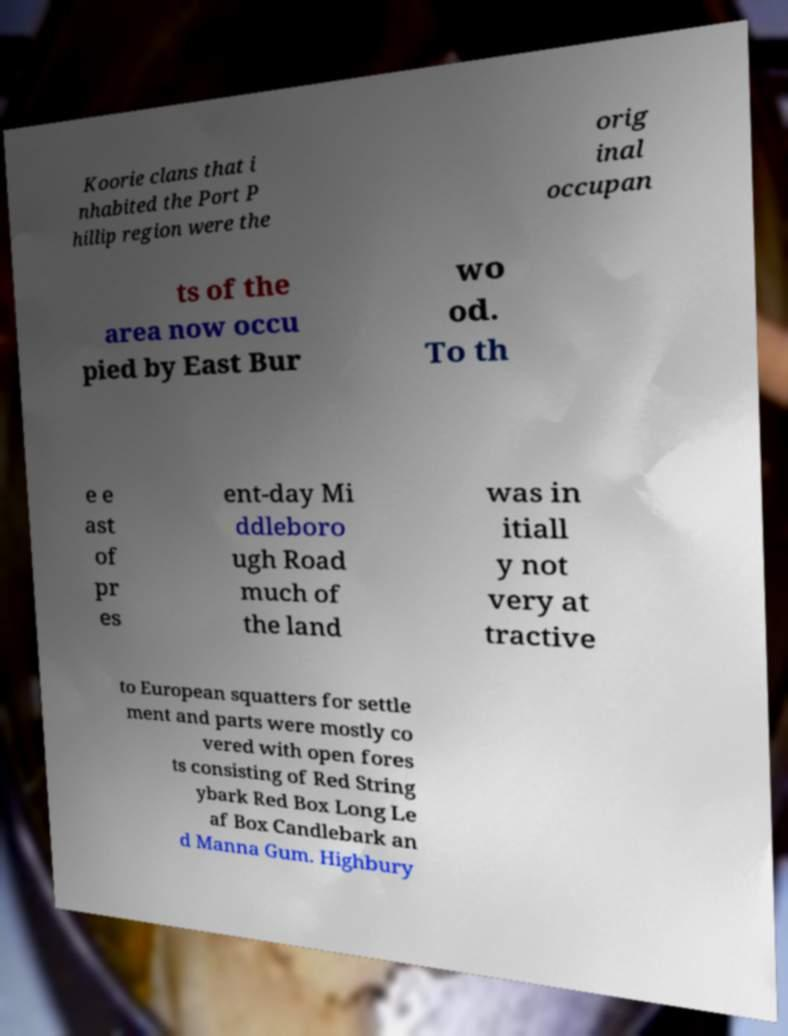Can you read and provide the text displayed in the image?This photo seems to have some interesting text. Can you extract and type it out for me? Koorie clans that i nhabited the Port P hillip region were the orig inal occupan ts of the area now occu pied by East Bur wo od. To th e e ast of pr es ent-day Mi ddleboro ugh Road much of the land was in itiall y not very at tractive to European squatters for settle ment and parts were mostly co vered with open fores ts consisting of Red String ybark Red Box Long Le af Box Candlebark an d Manna Gum. Highbury 